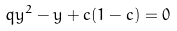<formula> <loc_0><loc_0><loc_500><loc_500>q y ^ { 2 } - y + c ( 1 - c ) = 0</formula> 